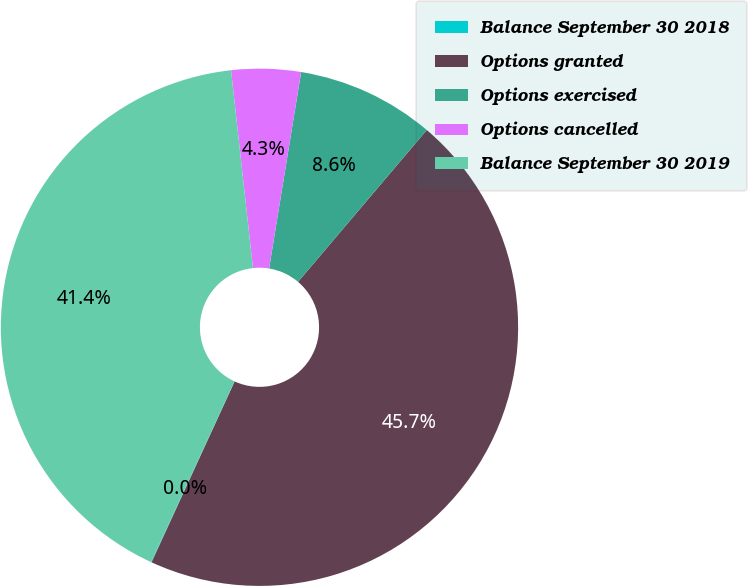Convert chart. <chart><loc_0><loc_0><loc_500><loc_500><pie_chart><fcel>Balance September 30 2018<fcel>Options granted<fcel>Options exercised<fcel>Options cancelled<fcel>Balance September 30 2019<nl><fcel>0.03%<fcel>45.66%<fcel>8.62%<fcel>4.33%<fcel>41.37%<nl></chart> 